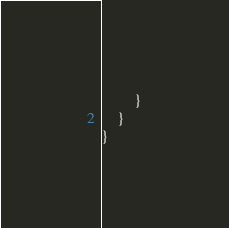Convert code to text. <code><loc_0><loc_0><loc_500><loc_500><_Kotlin_>		}
	}
}
</code> 